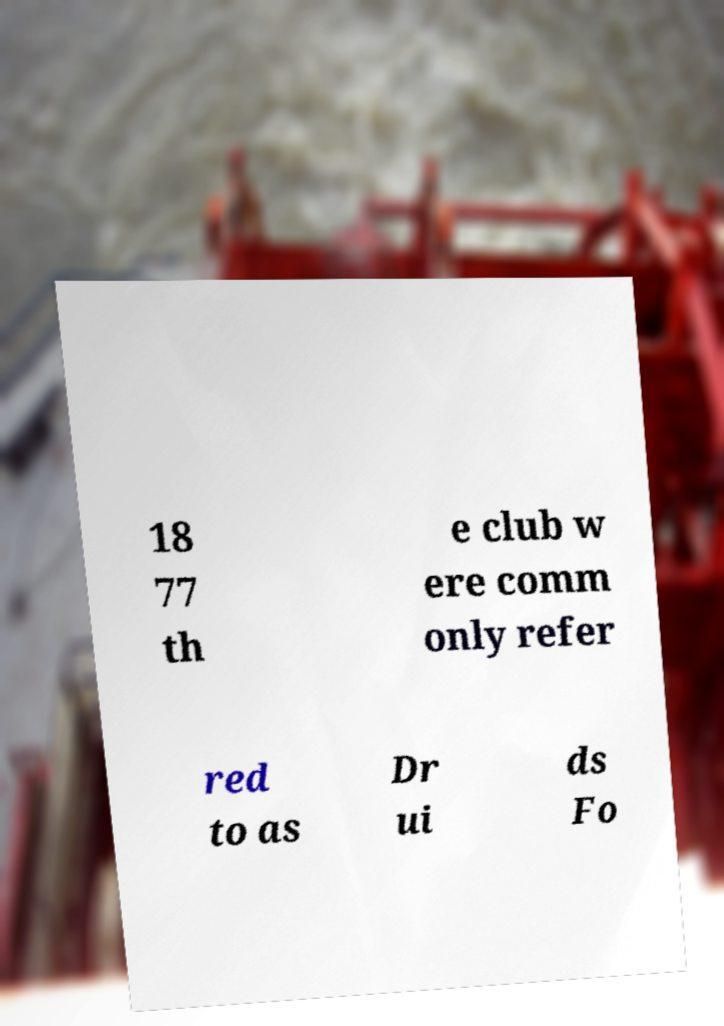For documentation purposes, I need the text within this image transcribed. Could you provide that? 18 77 th e club w ere comm only refer red to as Dr ui ds Fo 